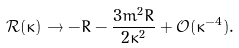Convert formula to latex. <formula><loc_0><loc_0><loc_500><loc_500>\mathcal { R } ( \kappa ) \to - R - \frac { 3 m ^ { 2 } R } { 2 \kappa ^ { 2 } } + \mathcal { O } ( \kappa ^ { - 4 } ) .</formula> 